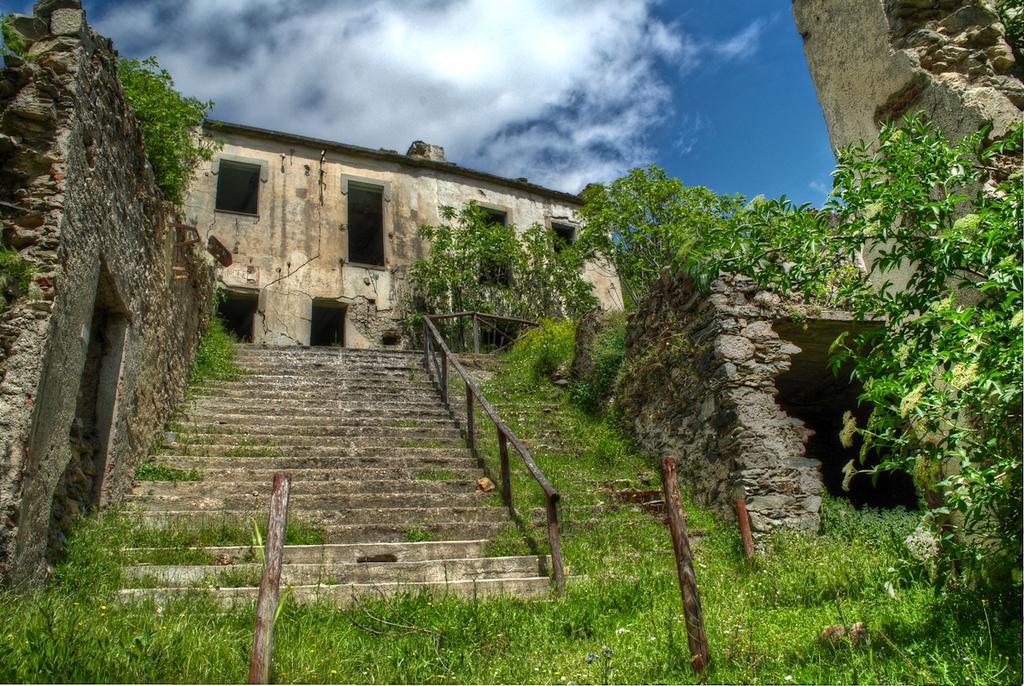What architectural feature is present in the image? There are steps in the image. What type of barrier is visible in the image? There is a wooden fence in the image. What surrounds the steps on both sides? There are walls on the left and right sides of the steps. What can be seen in the background of the image? Trees, at least one building, and the sky are visible in the background of the image. What type of flowers can be seen growing on the steps in the image? There are no flowers visible on the steps in the image. 